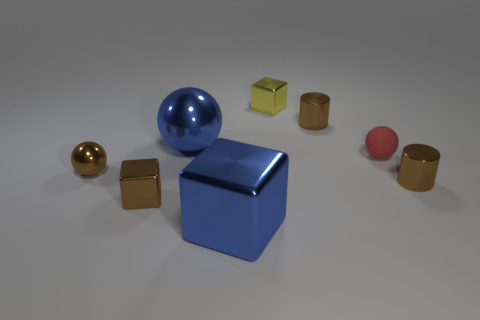Is there anything else that has the same material as the tiny red sphere?
Your answer should be compact. No. Are there fewer small yellow cubes than tiny purple matte cylinders?
Give a very brief answer. No. There is a brown thing that is the same shape as the red rubber object; what is its size?
Give a very brief answer. Small. Are the cube left of the blue cube and the small red object made of the same material?
Your answer should be compact. No. Does the tiny red matte thing have the same shape as the small yellow shiny thing?
Provide a short and direct response. No. How many things are blue things that are in front of the brown metallic sphere or blue balls?
Offer a very short reply. 2. There is a blue object that is the same material as the blue ball; what is its size?
Offer a terse response. Large. What number of spheres are the same color as the big shiny block?
Offer a terse response. 1. How many small objects are blue matte cubes or yellow cubes?
Your answer should be very brief. 1. There is a object that is the same color as the big block; what size is it?
Your answer should be very brief. Large. 